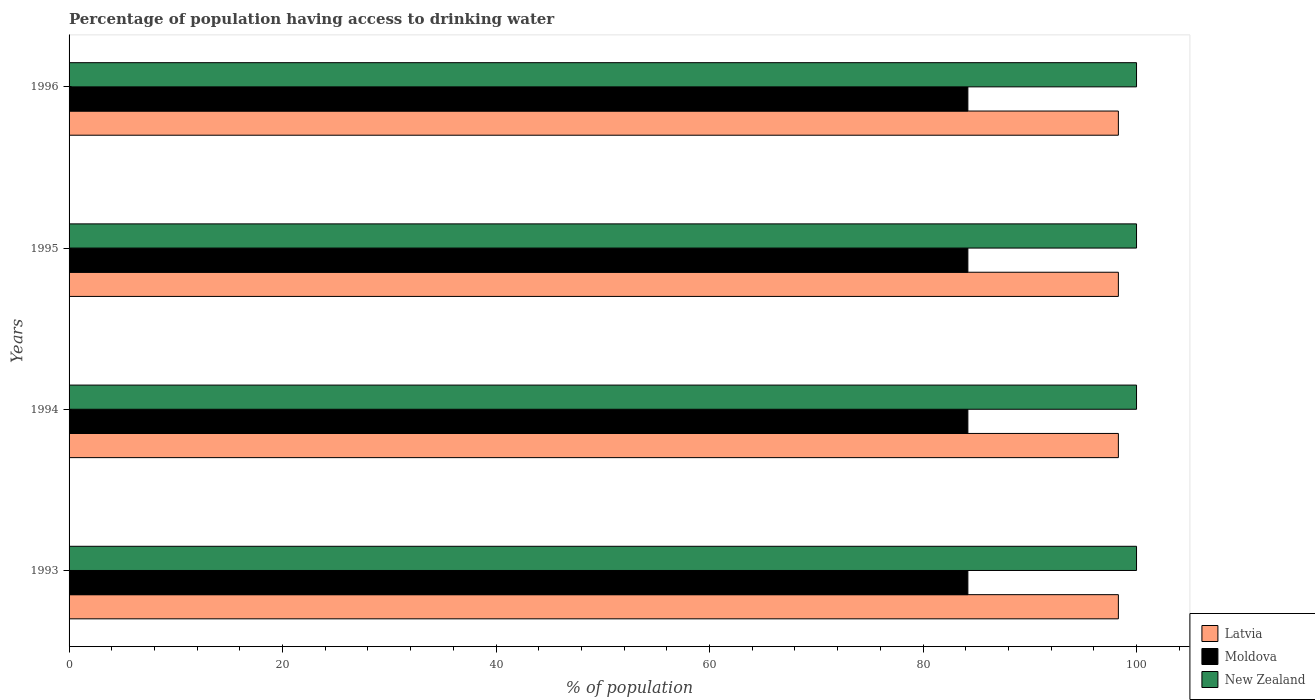How many different coloured bars are there?
Ensure brevity in your answer.  3. Are the number of bars per tick equal to the number of legend labels?
Your answer should be very brief. Yes. Are the number of bars on each tick of the Y-axis equal?
Your answer should be very brief. Yes. How many bars are there on the 3rd tick from the bottom?
Ensure brevity in your answer.  3. In how many cases, is the number of bars for a given year not equal to the number of legend labels?
Offer a terse response. 0. What is the percentage of population having access to drinking water in Moldova in 1995?
Offer a very short reply. 84.2. Across all years, what is the maximum percentage of population having access to drinking water in New Zealand?
Provide a short and direct response. 100. Across all years, what is the minimum percentage of population having access to drinking water in Latvia?
Make the answer very short. 98.3. In which year was the percentage of population having access to drinking water in Moldova maximum?
Your answer should be very brief. 1993. In which year was the percentage of population having access to drinking water in Latvia minimum?
Your response must be concise. 1993. What is the total percentage of population having access to drinking water in Latvia in the graph?
Give a very brief answer. 393.2. What is the difference between the percentage of population having access to drinking water in New Zealand in 1993 and that in 1994?
Your answer should be compact. 0. What is the difference between the percentage of population having access to drinking water in Latvia in 1994 and the percentage of population having access to drinking water in New Zealand in 1995?
Your answer should be compact. -1.7. What is the average percentage of population having access to drinking water in Moldova per year?
Ensure brevity in your answer.  84.2. In the year 1993, what is the difference between the percentage of population having access to drinking water in New Zealand and percentage of population having access to drinking water in Moldova?
Your answer should be very brief. 15.8. In how many years, is the percentage of population having access to drinking water in Latvia greater than 24 %?
Ensure brevity in your answer.  4. What is the ratio of the percentage of population having access to drinking water in New Zealand in 1993 to that in 1995?
Offer a very short reply. 1. Is the percentage of population having access to drinking water in New Zealand in 1994 less than that in 1995?
Give a very brief answer. No. Is the difference between the percentage of population having access to drinking water in New Zealand in 1994 and 1995 greater than the difference between the percentage of population having access to drinking water in Moldova in 1994 and 1995?
Provide a succinct answer. No. What is the difference between the highest and the second highest percentage of population having access to drinking water in New Zealand?
Make the answer very short. 0. What is the difference between the highest and the lowest percentage of population having access to drinking water in New Zealand?
Provide a succinct answer. 0. In how many years, is the percentage of population having access to drinking water in New Zealand greater than the average percentage of population having access to drinking water in New Zealand taken over all years?
Offer a very short reply. 0. What does the 1st bar from the top in 1993 represents?
Provide a short and direct response. New Zealand. What does the 2nd bar from the bottom in 1994 represents?
Offer a terse response. Moldova. How many bars are there?
Give a very brief answer. 12. How many years are there in the graph?
Your answer should be compact. 4. Are the values on the major ticks of X-axis written in scientific E-notation?
Give a very brief answer. No. Does the graph contain any zero values?
Your answer should be very brief. No. Where does the legend appear in the graph?
Make the answer very short. Bottom right. What is the title of the graph?
Your answer should be compact. Percentage of population having access to drinking water. What is the label or title of the X-axis?
Ensure brevity in your answer.  % of population. What is the label or title of the Y-axis?
Offer a terse response. Years. What is the % of population of Latvia in 1993?
Make the answer very short. 98.3. What is the % of population in Moldova in 1993?
Provide a succinct answer. 84.2. What is the % of population in New Zealand in 1993?
Provide a short and direct response. 100. What is the % of population of Latvia in 1994?
Your answer should be compact. 98.3. What is the % of population in Moldova in 1994?
Your answer should be compact. 84.2. What is the % of population of New Zealand in 1994?
Offer a very short reply. 100. What is the % of population of Latvia in 1995?
Keep it short and to the point. 98.3. What is the % of population of Moldova in 1995?
Your response must be concise. 84.2. What is the % of population in Latvia in 1996?
Provide a succinct answer. 98.3. What is the % of population in Moldova in 1996?
Give a very brief answer. 84.2. Across all years, what is the maximum % of population of Latvia?
Provide a short and direct response. 98.3. Across all years, what is the maximum % of population in Moldova?
Make the answer very short. 84.2. Across all years, what is the maximum % of population in New Zealand?
Provide a short and direct response. 100. Across all years, what is the minimum % of population of Latvia?
Keep it short and to the point. 98.3. Across all years, what is the minimum % of population of Moldova?
Provide a succinct answer. 84.2. What is the total % of population of Latvia in the graph?
Give a very brief answer. 393.2. What is the total % of population of Moldova in the graph?
Your answer should be compact. 336.8. What is the total % of population in New Zealand in the graph?
Your response must be concise. 400. What is the difference between the % of population in Moldova in 1993 and that in 1994?
Make the answer very short. 0. What is the difference between the % of population of Latvia in 1993 and that in 1996?
Make the answer very short. 0. What is the difference between the % of population of Latvia in 1994 and that in 1996?
Your answer should be compact. 0. What is the difference between the % of population of Moldova in 1994 and that in 1996?
Provide a succinct answer. 0. What is the difference between the % of population in New Zealand in 1995 and that in 1996?
Provide a short and direct response. 0. What is the difference between the % of population of Moldova in 1993 and the % of population of New Zealand in 1994?
Your answer should be compact. -15.8. What is the difference between the % of population of Latvia in 1993 and the % of population of Moldova in 1995?
Provide a short and direct response. 14.1. What is the difference between the % of population in Moldova in 1993 and the % of population in New Zealand in 1995?
Provide a succinct answer. -15.8. What is the difference between the % of population in Latvia in 1993 and the % of population in New Zealand in 1996?
Offer a very short reply. -1.7. What is the difference between the % of population of Moldova in 1993 and the % of population of New Zealand in 1996?
Make the answer very short. -15.8. What is the difference between the % of population in Latvia in 1994 and the % of population in Moldova in 1995?
Give a very brief answer. 14.1. What is the difference between the % of population in Moldova in 1994 and the % of population in New Zealand in 1995?
Your answer should be very brief. -15.8. What is the difference between the % of population in Latvia in 1994 and the % of population in Moldova in 1996?
Your answer should be very brief. 14.1. What is the difference between the % of population in Latvia in 1994 and the % of population in New Zealand in 1996?
Offer a terse response. -1.7. What is the difference between the % of population of Moldova in 1994 and the % of population of New Zealand in 1996?
Ensure brevity in your answer.  -15.8. What is the difference between the % of population of Latvia in 1995 and the % of population of Moldova in 1996?
Offer a terse response. 14.1. What is the difference between the % of population of Moldova in 1995 and the % of population of New Zealand in 1996?
Your answer should be very brief. -15.8. What is the average % of population in Latvia per year?
Keep it short and to the point. 98.3. What is the average % of population of Moldova per year?
Provide a short and direct response. 84.2. What is the average % of population in New Zealand per year?
Your answer should be compact. 100. In the year 1993, what is the difference between the % of population of Latvia and % of population of New Zealand?
Your response must be concise. -1.7. In the year 1993, what is the difference between the % of population of Moldova and % of population of New Zealand?
Offer a very short reply. -15.8. In the year 1994, what is the difference between the % of population of Latvia and % of population of Moldova?
Provide a succinct answer. 14.1. In the year 1994, what is the difference between the % of population of Latvia and % of population of New Zealand?
Offer a terse response. -1.7. In the year 1994, what is the difference between the % of population of Moldova and % of population of New Zealand?
Offer a terse response. -15.8. In the year 1995, what is the difference between the % of population of Latvia and % of population of Moldova?
Offer a very short reply. 14.1. In the year 1995, what is the difference between the % of population in Latvia and % of population in New Zealand?
Your response must be concise. -1.7. In the year 1995, what is the difference between the % of population of Moldova and % of population of New Zealand?
Make the answer very short. -15.8. In the year 1996, what is the difference between the % of population in Moldova and % of population in New Zealand?
Give a very brief answer. -15.8. What is the ratio of the % of population in Latvia in 1993 to that in 1995?
Ensure brevity in your answer.  1. What is the ratio of the % of population in New Zealand in 1993 to that in 1995?
Your answer should be compact. 1. What is the ratio of the % of population in Moldova in 1993 to that in 1996?
Make the answer very short. 1. What is the ratio of the % of population in New Zealand in 1993 to that in 1996?
Provide a succinct answer. 1. What is the ratio of the % of population of Latvia in 1994 to that in 1995?
Your answer should be compact. 1. What is the ratio of the % of population in Latvia in 1994 to that in 1996?
Keep it short and to the point. 1. What is the ratio of the % of population of Moldova in 1994 to that in 1996?
Give a very brief answer. 1. What is the ratio of the % of population of Moldova in 1995 to that in 1996?
Provide a succinct answer. 1. What is the ratio of the % of population of New Zealand in 1995 to that in 1996?
Provide a short and direct response. 1. What is the difference between the highest and the second highest % of population of Moldova?
Your response must be concise. 0. What is the difference between the highest and the lowest % of population in Latvia?
Your response must be concise. 0. What is the difference between the highest and the lowest % of population in Moldova?
Your response must be concise. 0. 